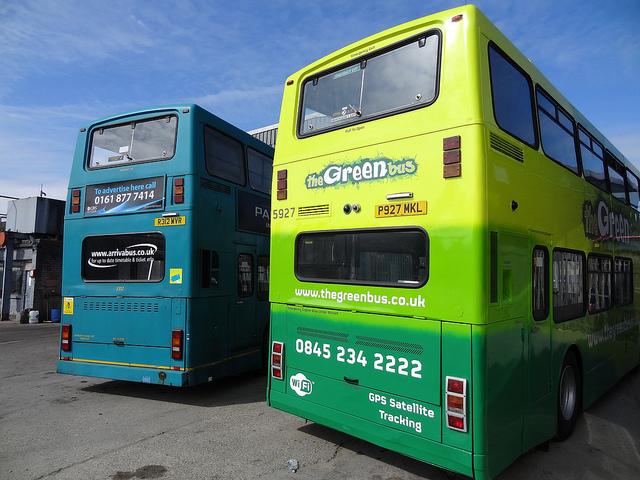What the bus number of the green bus?
Give a very brief answer. 5927. What is the phone number on the green bus?
Short answer required. 0845 234 2222. What is the website address for the bus company?
Concise answer only. Wwwthegreenbuscouk. 